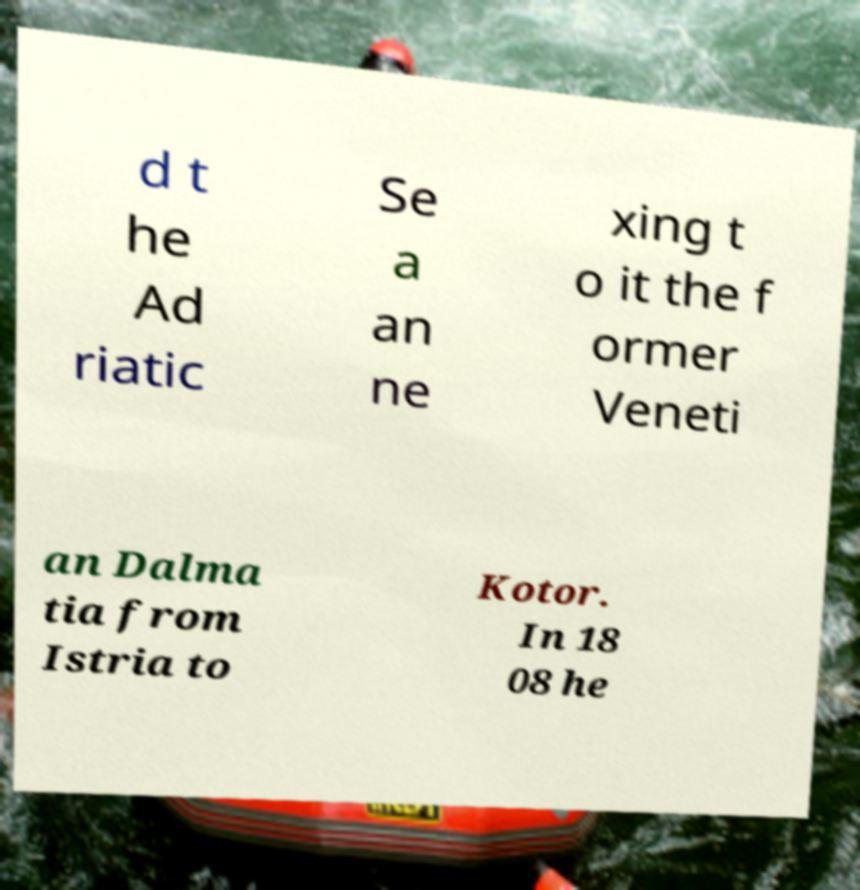For documentation purposes, I need the text within this image transcribed. Could you provide that? d t he Ad riatic Se a an ne xing t o it the f ormer Veneti an Dalma tia from Istria to Kotor. In 18 08 he 